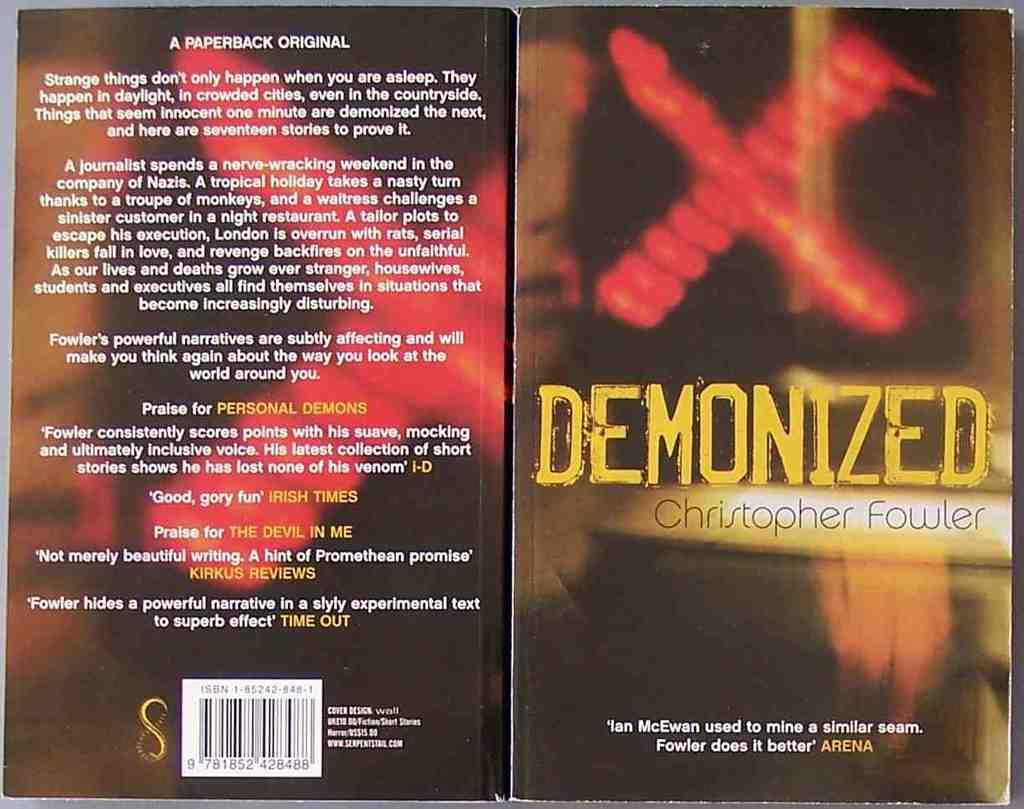<image>
Share a concise interpretation of the image provided. a book that is titled 'demonized' by the author Christopher fowler 